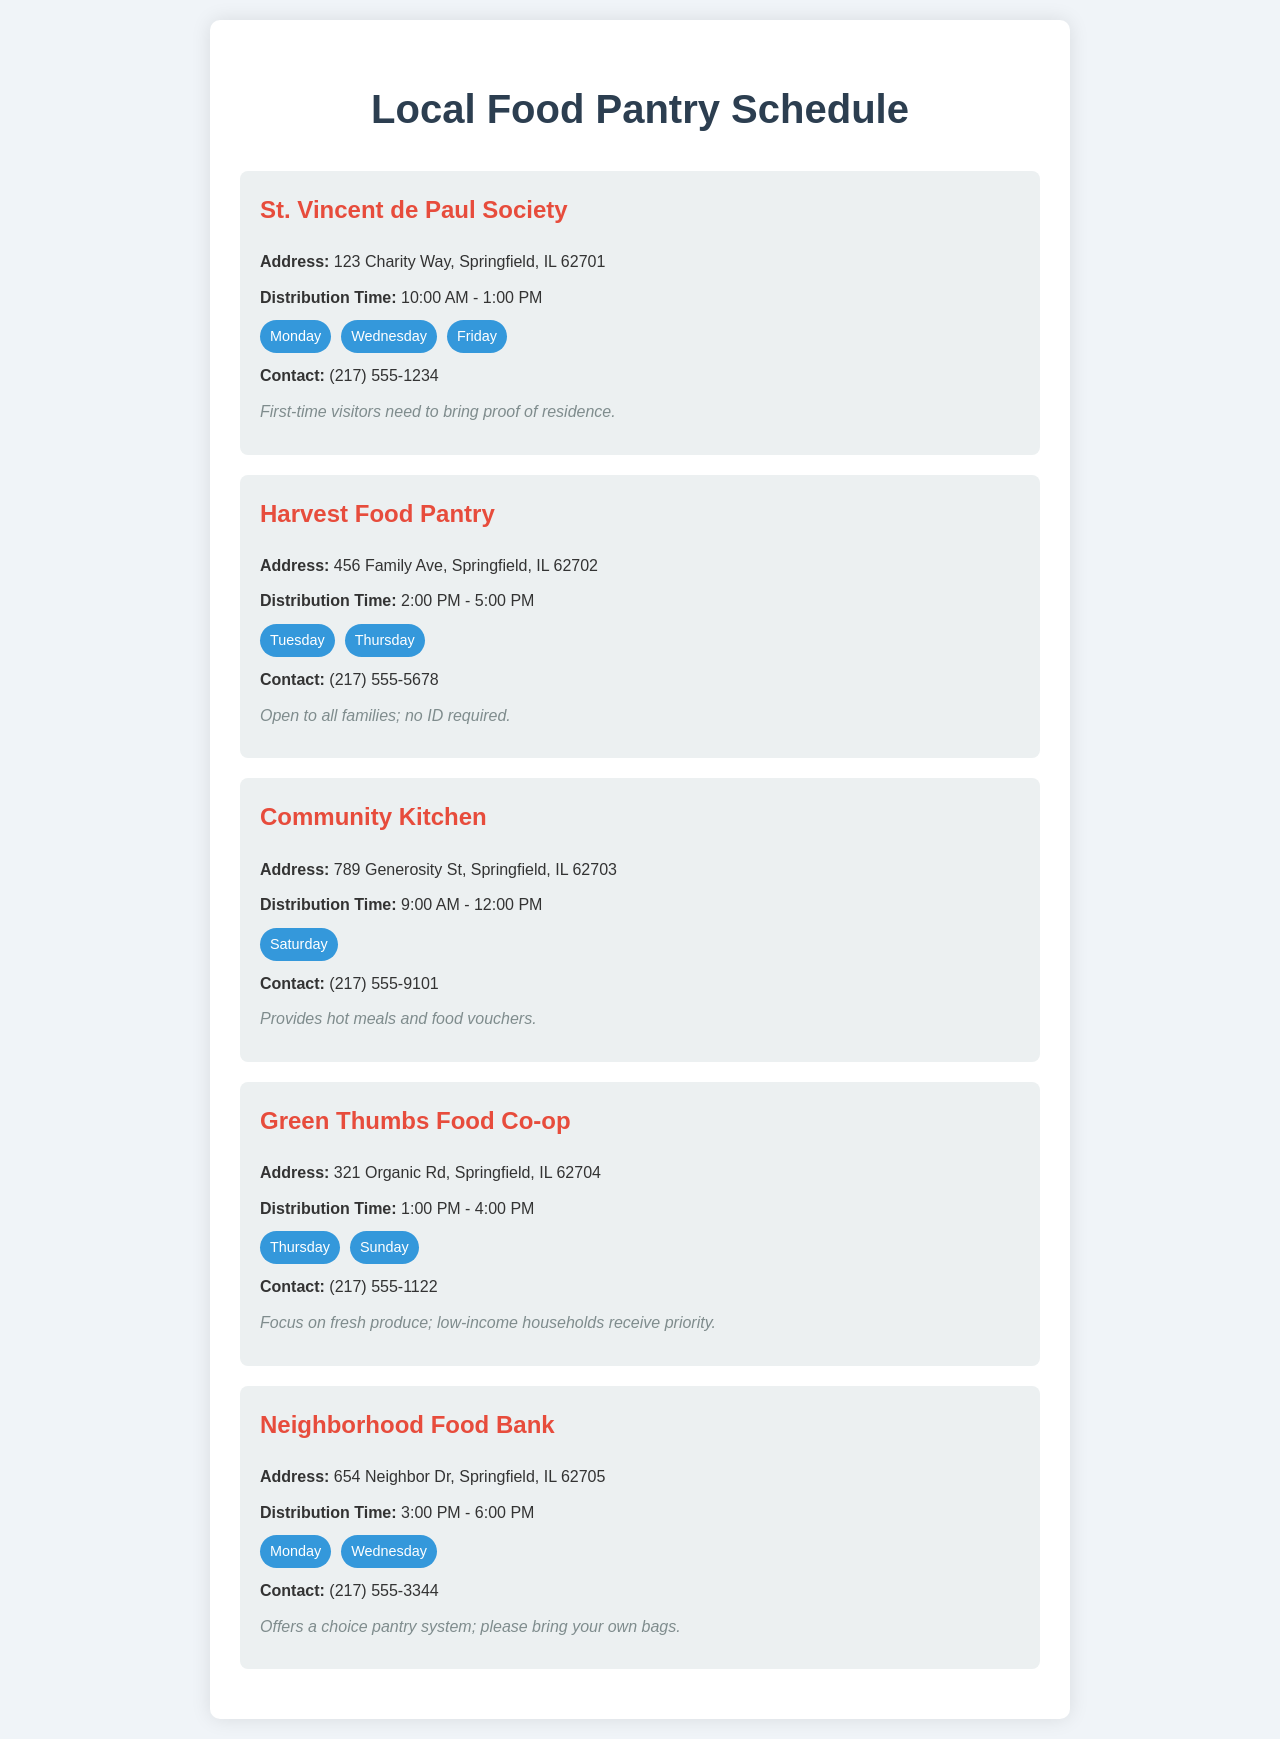What is the address of St. Vincent de Paul Society? The address is specifically listed in the document as 123 Charity Way, Springfield, IL 62701.
Answer: 123 Charity Way, Springfield, IL 62701 What are the distribution days for Harvest Food Pantry? The document lists the specific days for Harvest Food Pantry's distribution as Tuesday and Thursday.
Answer: Tuesday, Thursday What is the contact number for Community Kitchen? The document provides the contact number for Community Kitchen, which is (217) 555-9101.
Answer: (217) 555-9101 Which food pantry provides hot meals? The document mentions Community Kitchen as the pantry that provides hot meals and food vouchers.
Answer: Community Kitchen What are the distribution hours for Neighborhood Food Bank? The distribution hours are stated as 3:00 PM - 6:00 PM in the document.
Answer: 3:00 PM - 6:00 PM How many pantries have distribution days on Monday? By analyzing the days listed, there are three pantries that distribute on Monday: St. Vincent de Paul Society, Neighborhood Food Bank, and Green Thumbs Food Co-op.
Answer: 3 What is the primary focus of Green Thumbs Food Co-op? The document specifies that Green Thumbs Food Co-op focuses on fresh produce and gives priority to low-income households.
Answer: Fresh produce What is required for first-time visitors at St. Vincent de Paul Society? The notes in the document indicate that first-time visitors need to bring proof of residence.
Answer: Proof of residence 